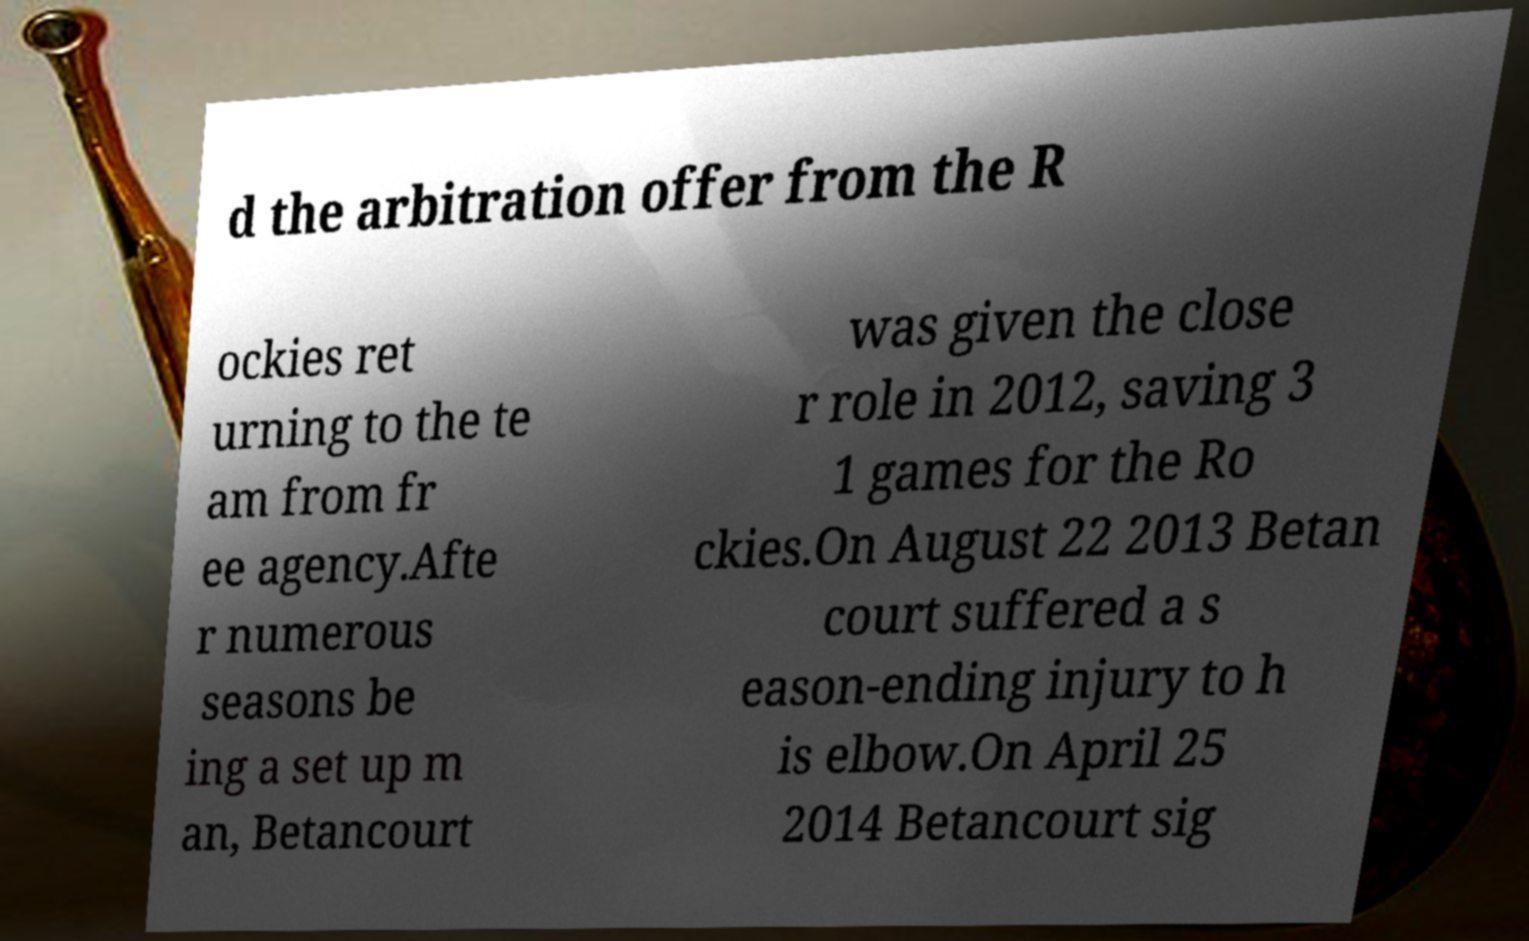Please read and relay the text visible in this image. What does it say? d the arbitration offer from the R ockies ret urning to the te am from fr ee agency.Afte r numerous seasons be ing a set up m an, Betancourt was given the close r role in 2012, saving 3 1 games for the Ro ckies.On August 22 2013 Betan court suffered a s eason-ending injury to h is elbow.On April 25 2014 Betancourt sig 